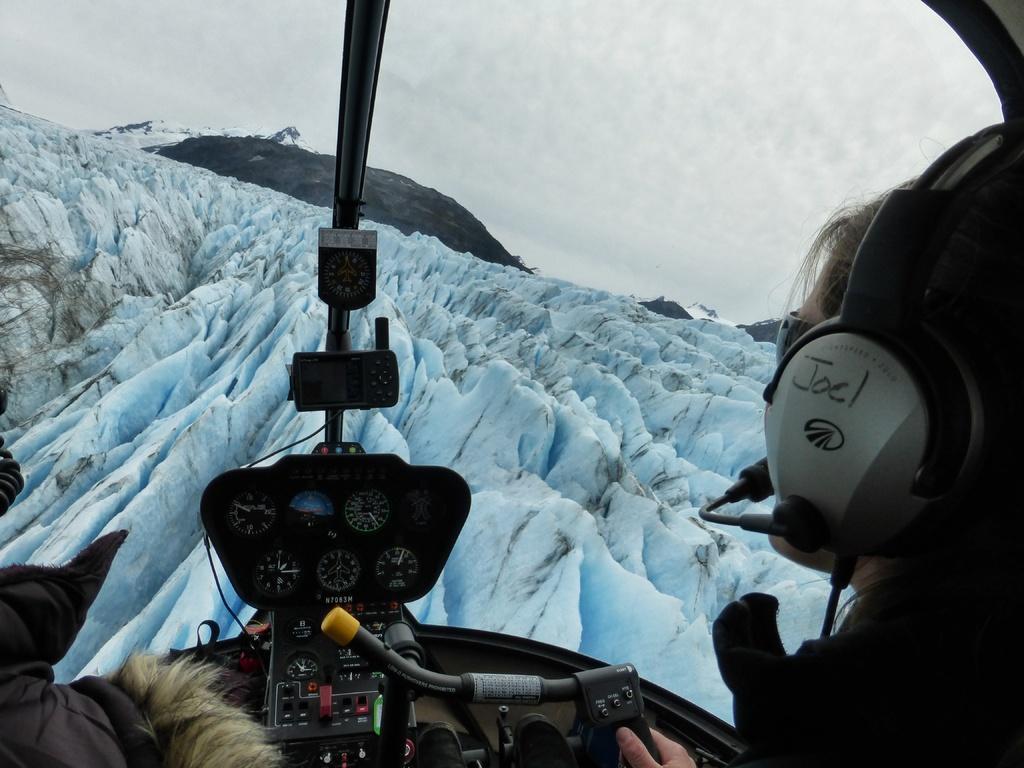Describe this image in one or two sentences. Here we can see the inside view of an airplane. This is a mountain and there is a person. In the background there is sky. 